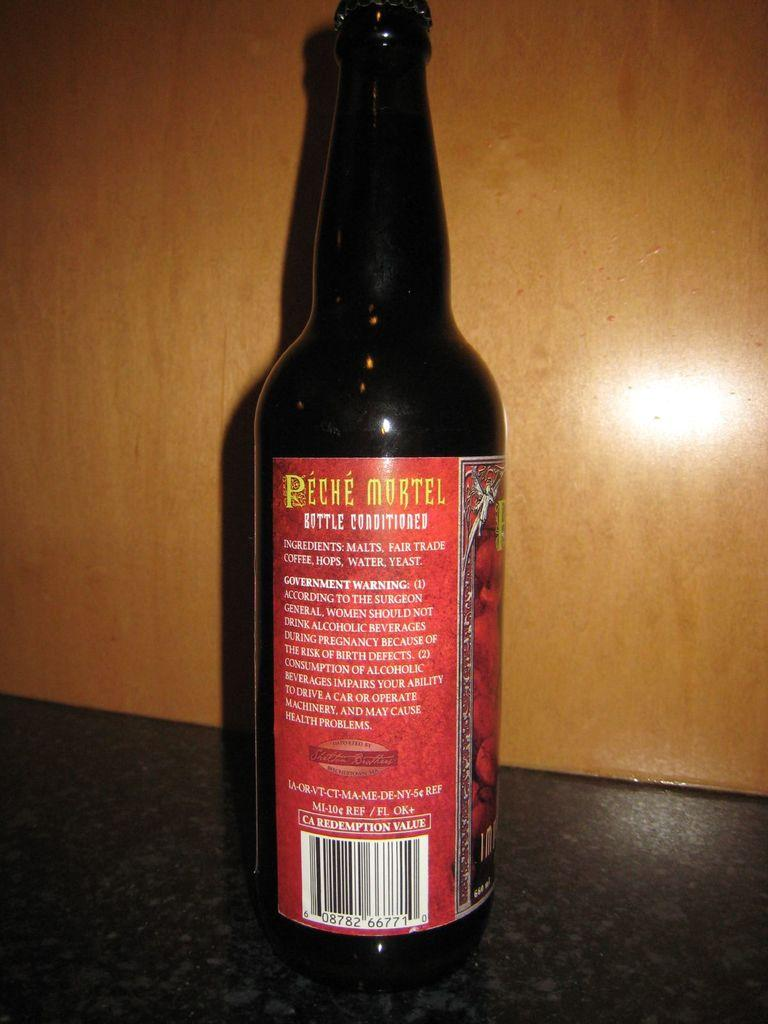<image>
Write a terse but informative summary of the picture. A bottle of Peche Mortel beer that says bottle conditioned. 